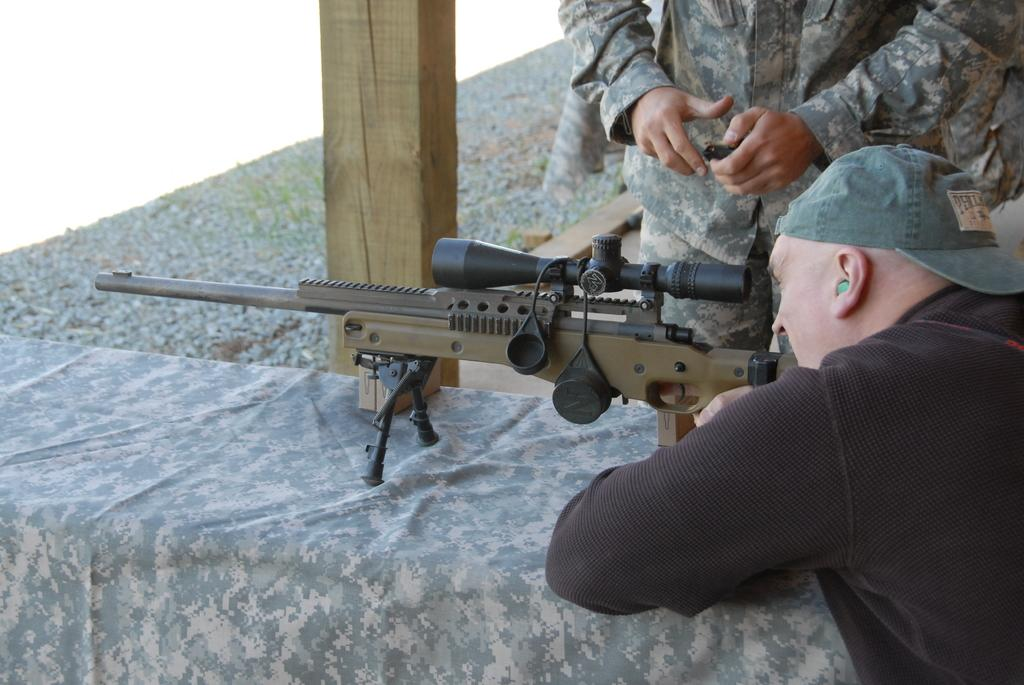How many people are present in the image? There are two people in the image. What object can be seen on the table in the image? There is a gun on the table in the image. Can you describe the wooden object in the image? The wooden object in the image is not specified, but it is mentioned as being present. What color is the background of the image? The background of the image is white. What type of health advice is being given in the image? There is no indication of health advice being given in the image; it features two people and a gun on a table. Can you describe the prose written on the wooden object in the image? There is no mention of prose or writing on the wooden object in the image. 